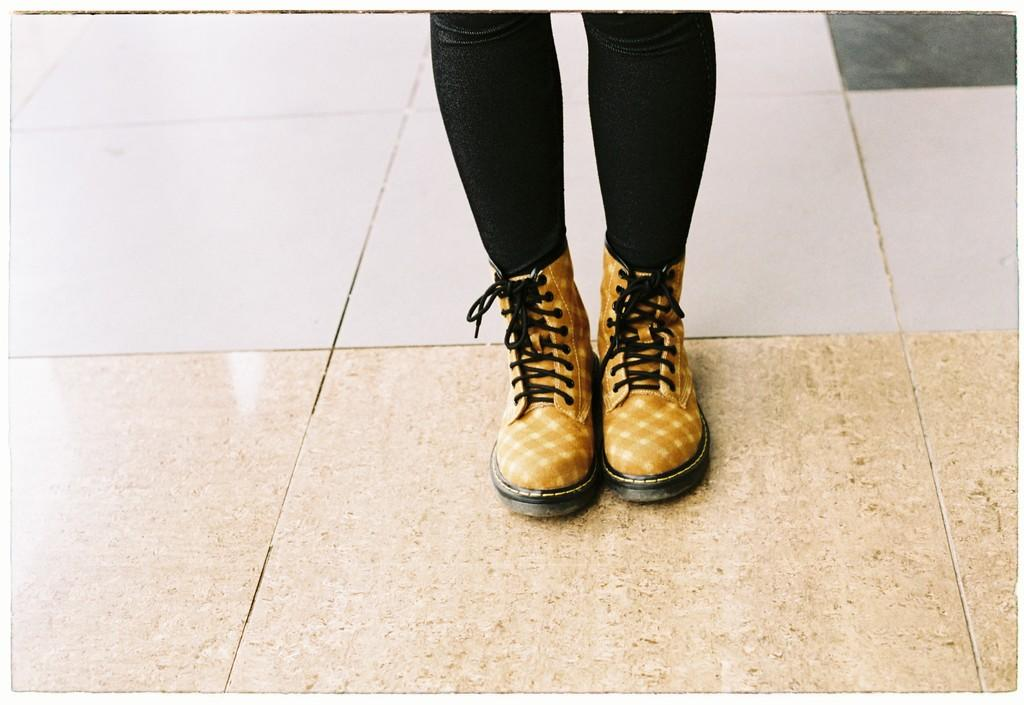What is present in the image? There is a person in the image. What part of the person's body is visible in the image? The person's legs are visible in the image. What type of footwear is the person wearing? The person is wearing boots. What type of flooring is present in the image? The floor in the image is tiled. What activity is the person participating in on the marble channel in the image? There is no marble channel present in the image, nor is there any activity involving a marble channel. 